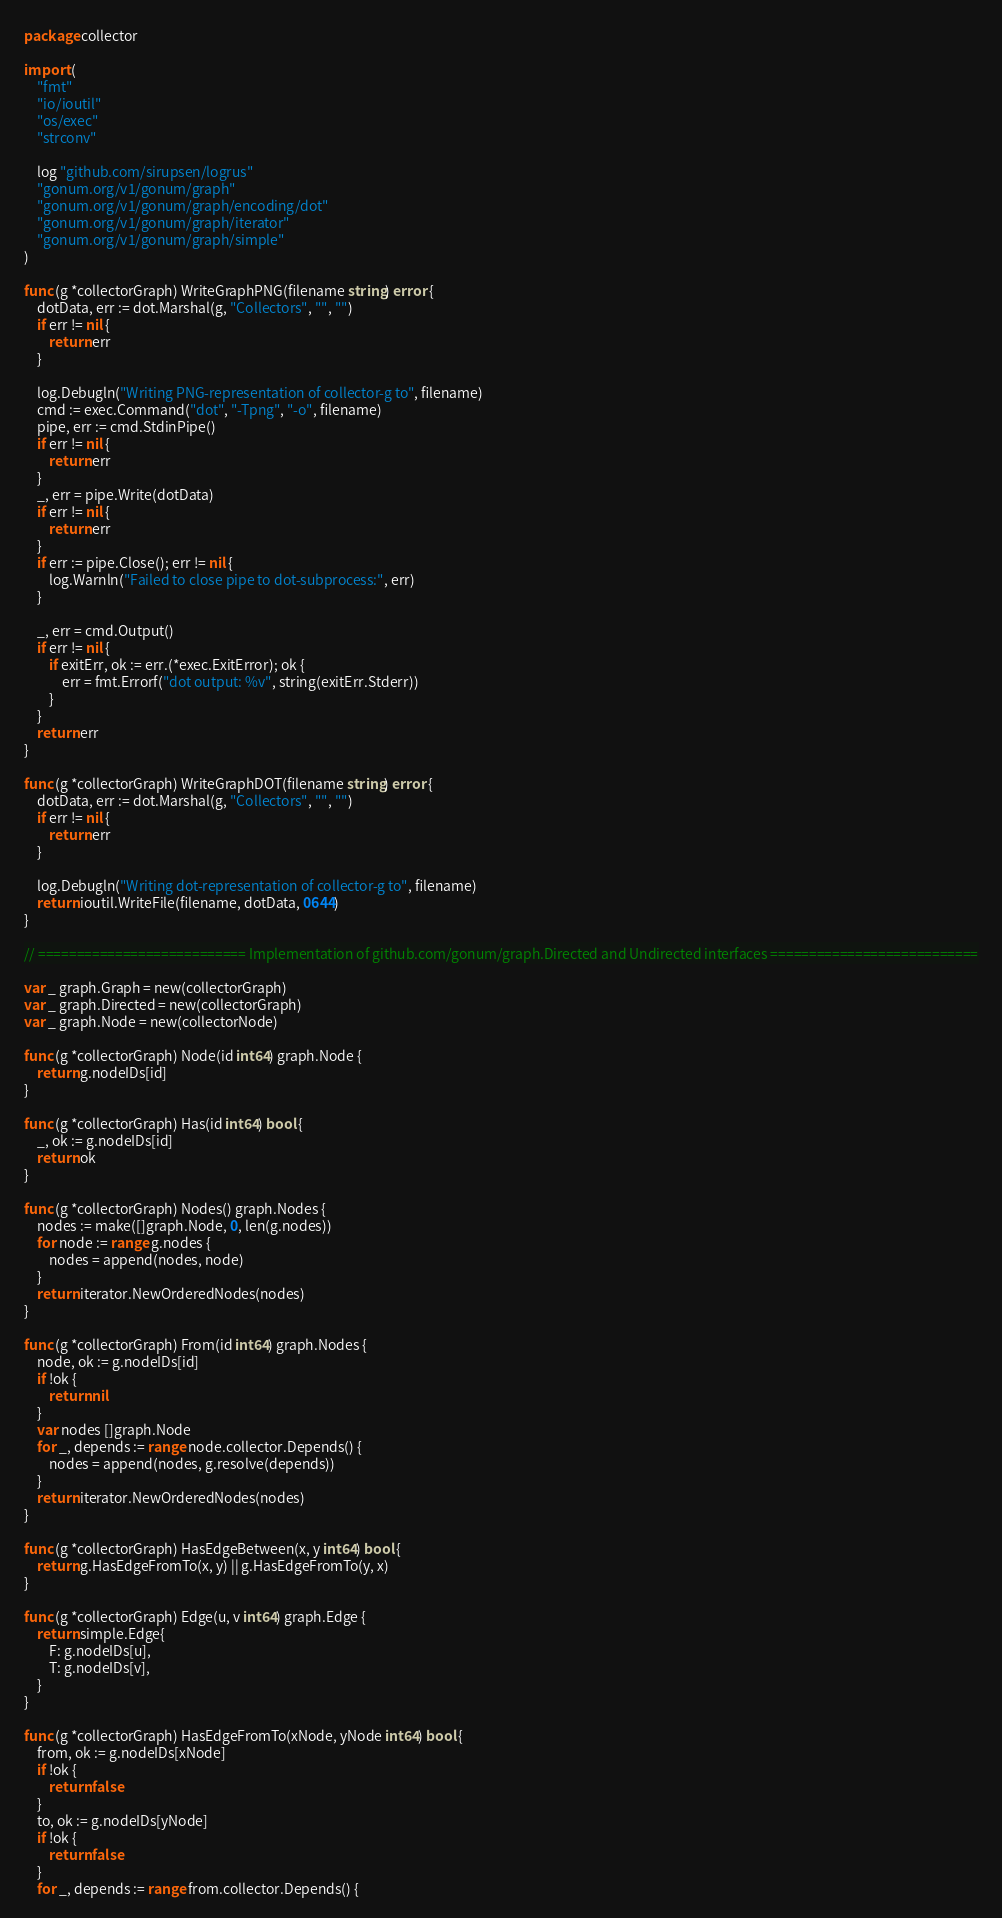<code> <loc_0><loc_0><loc_500><loc_500><_Go_>package collector

import (
	"fmt"
	"io/ioutil"
	"os/exec"
	"strconv"

	log "github.com/sirupsen/logrus"
	"gonum.org/v1/gonum/graph"
	"gonum.org/v1/gonum/graph/encoding/dot"
	"gonum.org/v1/gonum/graph/iterator"
	"gonum.org/v1/gonum/graph/simple"
)

func (g *collectorGraph) WriteGraphPNG(filename string) error {
	dotData, err := dot.Marshal(g, "Collectors", "", "")
	if err != nil {
		return err
	}

	log.Debugln("Writing PNG-representation of collector-g to", filename)
	cmd := exec.Command("dot", "-Tpng", "-o", filename)
	pipe, err := cmd.StdinPipe()
	if err != nil {
		return err
	}
	_, err = pipe.Write(dotData)
	if err != nil {
		return err
	}
	if err := pipe.Close(); err != nil {
		log.Warnln("Failed to close pipe to dot-subprocess:", err)
	}

	_, err = cmd.Output()
	if err != nil {
		if exitErr, ok := err.(*exec.ExitError); ok {
			err = fmt.Errorf("dot output: %v", string(exitErr.Stderr))
		}
	}
	return err
}

func (g *collectorGraph) WriteGraphDOT(filename string) error {
	dotData, err := dot.Marshal(g, "Collectors", "", "")
	if err != nil {
		return err
	}

	log.Debugln("Writing dot-representation of collector-g to", filename)
	return ioutil.WriteFile(filename, dotData, 0644)
}

// =========================== Implementation of github.com/gonum/graph.Directed and Undirected interfaces ===========================

var _ graph.Graph = new(collectorGraph)
var _ graph.Directed = new(collectorGraph)
var _ graph.Node = new(collectorNode)

func (g *collectorGraph) Node(id int64) graph.Node {
	return g.nodeIDs[id]
}

func (g *collectorGraph) Has(id int64) bool {
	_, ok := g.nodeIDs[id]
	return ok
}

func (g *collectorGraph) Nodes() graph.Nodes {
	nodes := make([]graph.Node, 0, len(g.nodes))
	for node := range g.nodes {
		nodes = append(nodes, node)
	}
	return iterator.NewOrderedNodes(nodes)
}

func (g *collectorGraph) From(id int64) graph.Nodes {
	node, ok := g.nodeIDs[id]
	if !ok {
		return nil
	}
	var nodes []graph.Node
	for _, depends := range node.collector.Depends() {
		nodes = append(nodes, g.resolve(depends))
	}
	return iterator.NewOrderedNodes(nodes)
}

func (g *collectorGraph) HasEdgeBetween(x, y int64) bool {
	return g.HasEdgeFromTo(x, y) || g.HasEdgeFromTo(y, x)
}

func (g *collectorGraph) Edge(u, v int64) graph.Edge {
	return simple.Edge{
		F: g.nodeIDs[u],
		T: g.nodeIDs[v],
	}
}

func (g *collectorGraph) HasEdgeFromTo(xNode, yNode int64) bool {
	from, ok := g.nodeIDs[xNode]
	if !ok {
		return false
	}
	to, ok := g.nodeIDs[yNode]
	if !ok {
		return false
	}
	for _, depends := range from.collector.Depends() {</code> 